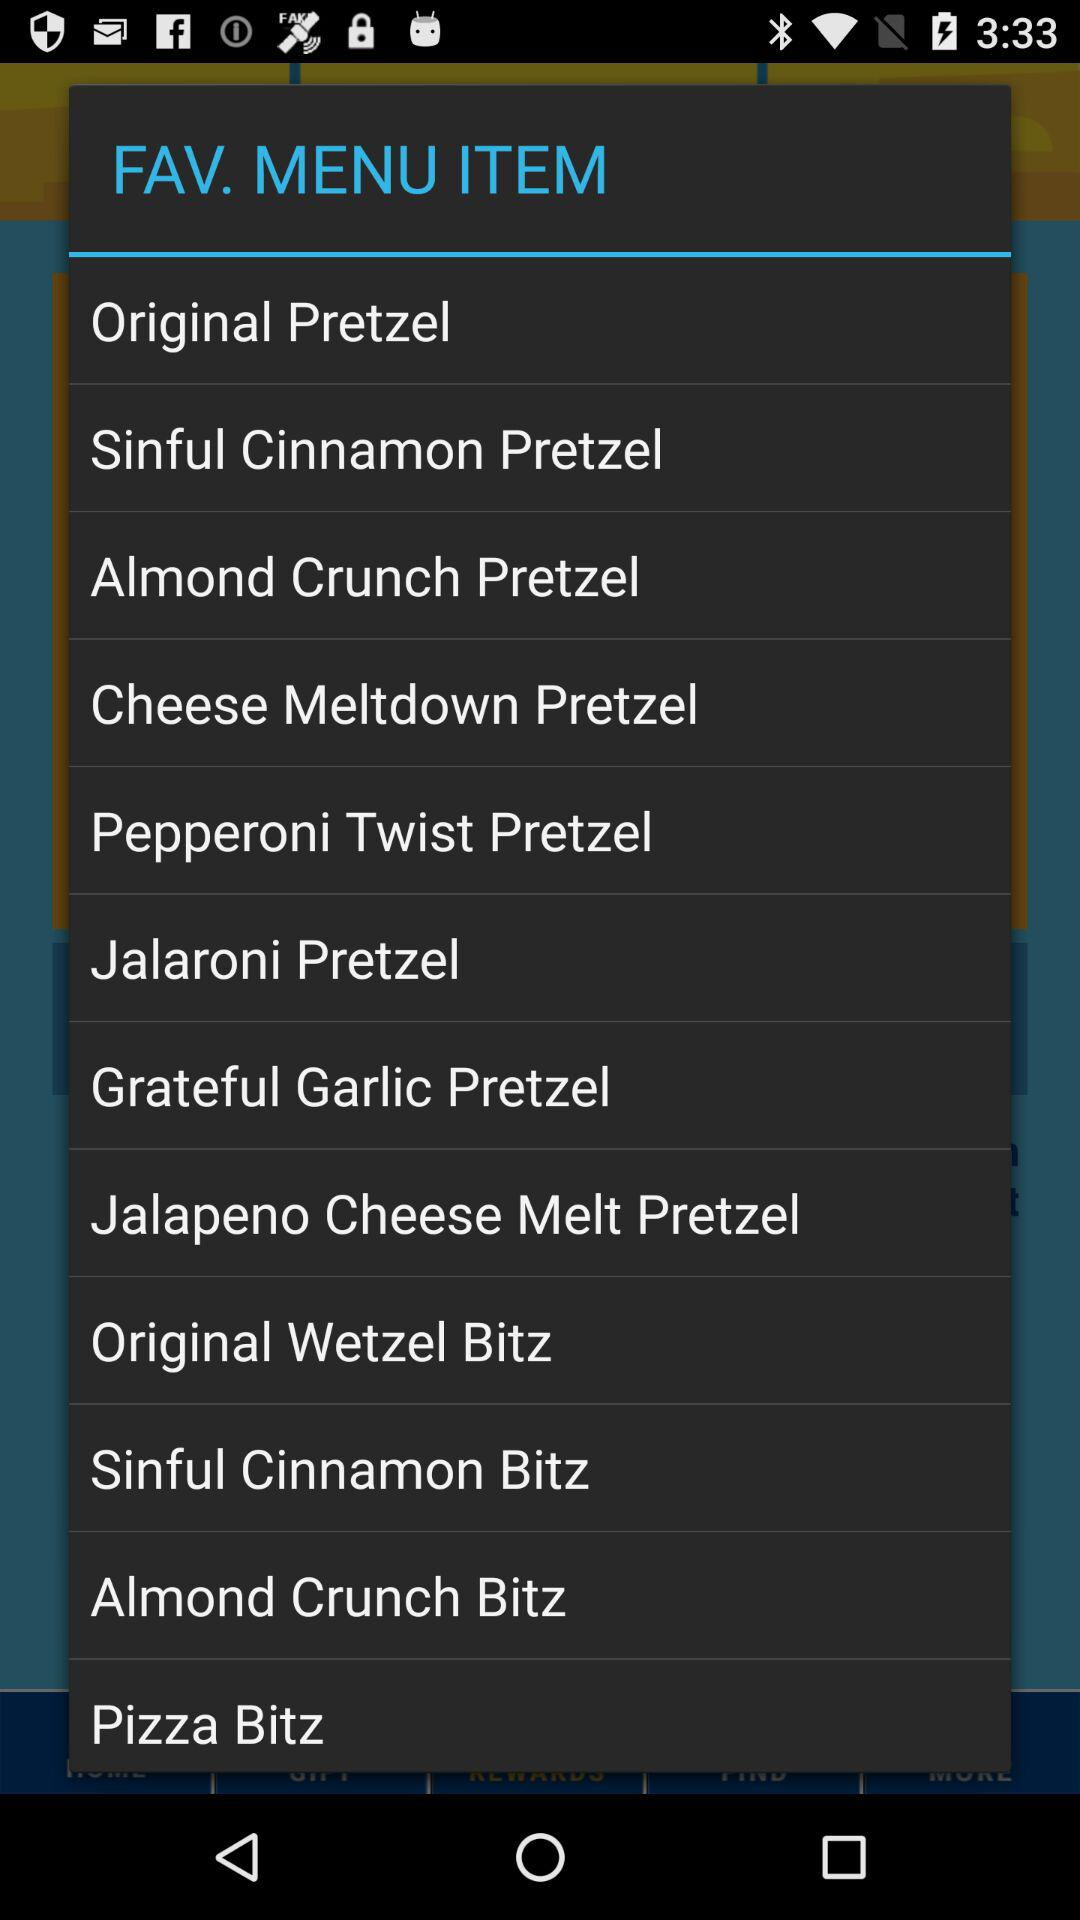How many pretzel items are there in the favorites menu?
Answer the question using a single word or phrase. 8 